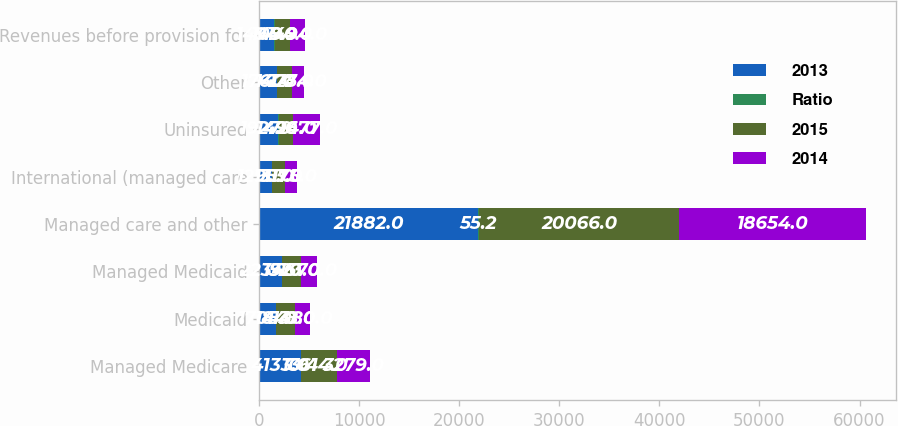<chart> <loc_0><loc_0><loc_500><loc_500><stacked_bar_chart><ecel><fcel>Managed Medicare<fcel>Medicaid<fcel>Managed Medicaid<fcel>Managed care and other<fcel>International (managed care<fcel>Uninsured<fcel>Other<fcel>Revenues before provision for<nl><fcel>2013<fcel>4133<fcel>1705<fcel>2234<fcel>21882<fcel>1295<fcel>1927<fcel>1761<fcel>1494<nl><fcel>Ratio<fcel>10.4<fcel>4.3<fcel>5.6<fcel>55.2<fcel>3.3<fcel>4.9<fcel>4.4<fcel>109.9<nl><fcel>2015<fcel>3614<fcel>1848<fcel>1923<fcel>20066<fcel>1311<fcel>1494<fcel>1477<fcel>1494<nl><fcel>2014<fcel>3279<fcel>1480<fcel>1570<fcel>18654<fcel>1175<fcel>2677<fcel>1254<fcel>1494<nl></chart> 